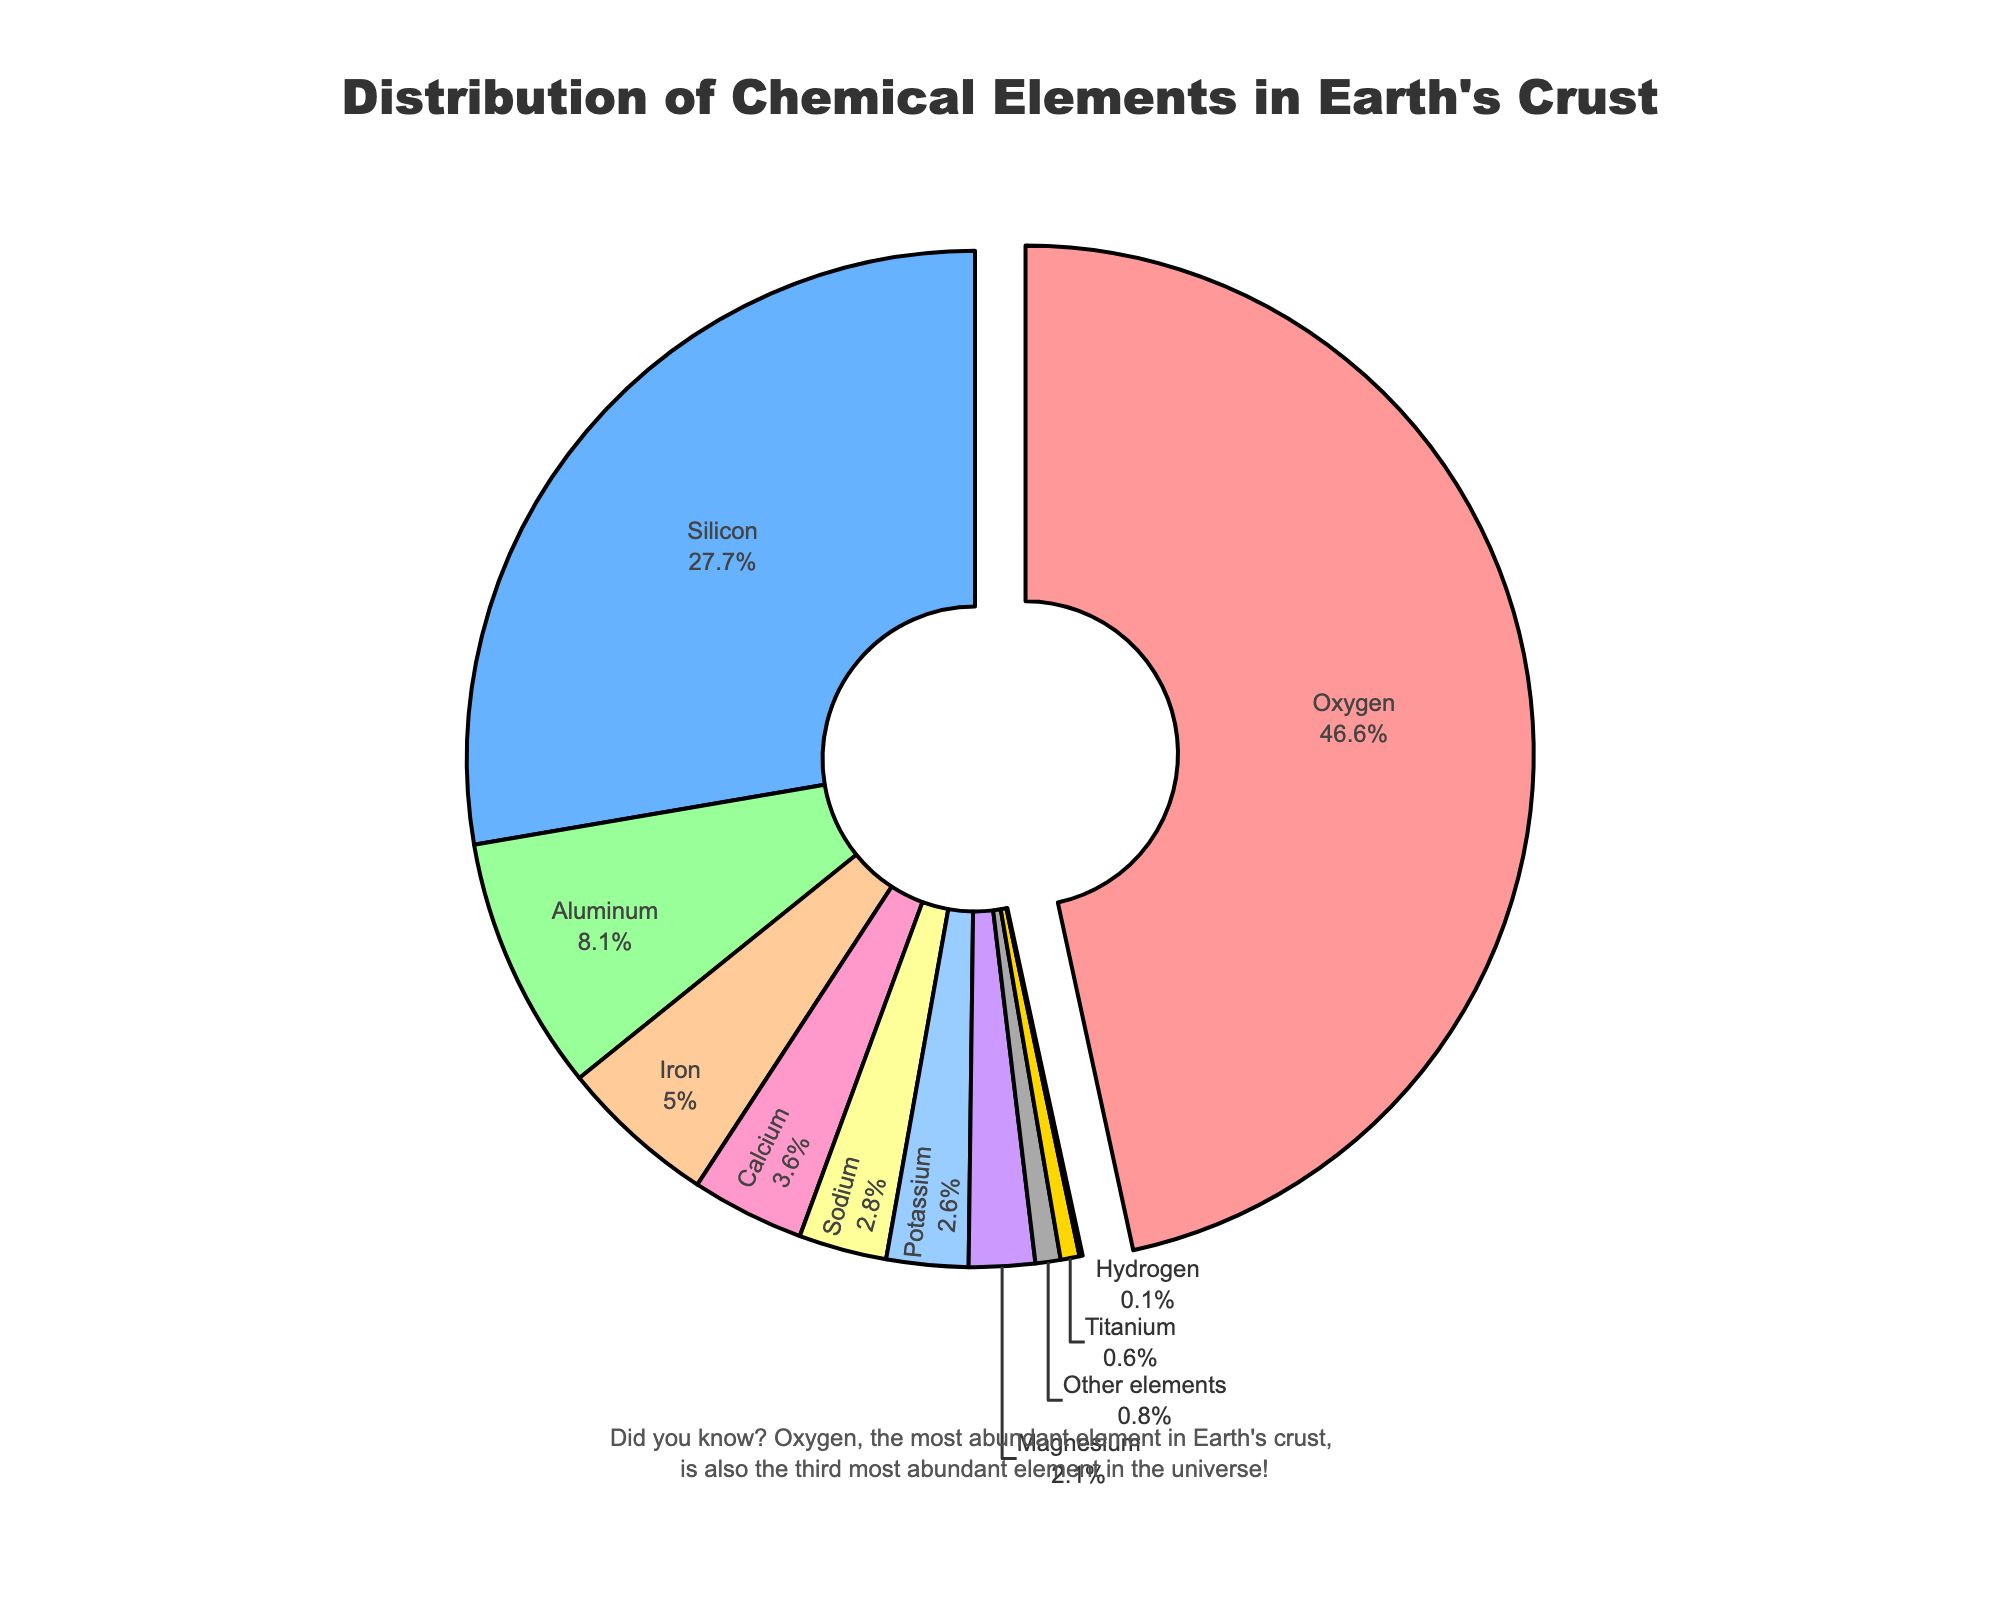what is the most abundant element in the Earth's crust? By examining the pie chart, the segment with the highest percentage value signifies the most abundant element. Oxygen has the largest segment with 46.6%.
Answer: Oxygen What is the combined percentage of Silicon and Aluminum in the Earth's crust? Add the percentages of Silicon (27.7%) and Aluminum (8.1%) together: 27.7 + 8.1 = 35.8%.
Answer: 35.8% Which element has a larger percentage in the Earth's crust, Calcium or Sodium? Compare the segments for Calcium (3.6%) and Sodium (2.8%). Calcium has a larger percentage than Sodium.
Answer: Calcium Is the percentage of Iron in the Earth's crust higher or lower than that of Aluminum? Compare the segments for Iron (5.0%) and Aluminum (8.1%). The percentage of Iron is lower than that of Aluminum.
Answer: Lower How much larger is the percentage of Oxygen compared to Iron in the Earth's crust? Subtract the percentage of Iron (5.0%) from the percentage of Oxygen (46.6%): 46.6 - 5.0 = 41.6%.
Answer: 41.6% What elements have percentages less than 3% in the Earth's crust? Identify the segments with percentages less than 3%: Titanium (0.6%), Potassium (2.6%), Magnesium (2.1%), Hydrogen (0.1%), Sodium (2.8%), and Other elements (0.8%).
Answer: Titanium, Potassium, Magnesium, Hydrogen, Sodium, Other elements Are the percentages of Potassium and Magnesium in the Earth's crust equal or different? Compare the segments for Potassium (2.6%) and Magnesium (2.1%). The percentages are different.
Answer: Different What is the total percentage of elements other than Oxygen, Silicon, and Aluminum in the Earth's crust? Subtract the sum of percentages of Oxygen (46.6%), Silicon (27.7%), and Aluminum (8.1%) from 100%: 100 - (46.6 + 27.7 + 8.1) = 17.6%.
Answer: 17.6% Which element category has only 0.1% representation in the Earth's crust? Identify the segment with 0.1% representation, which is Hydrogen.
Answer: Hydrogen What is the percentage difference between Sodium and Potassium in the Earth's crust? Subtract the percentage of Potassium (2.6%) from the percentage of Sodium (2.8%): 2.8 - 2.6 = 0.2%.
Answer: 0.2% 